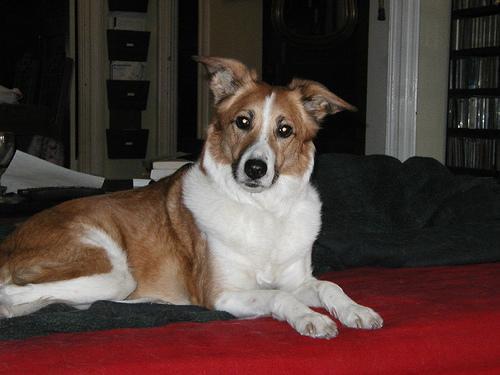How many dogs are visible?
Give a very brief answer. 1. 